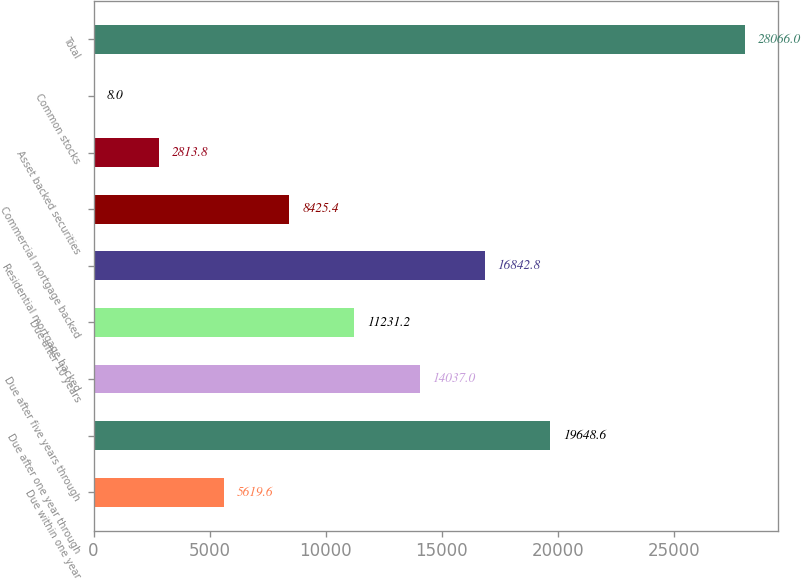Convert chart. <chart><loc_0><loc_0><loc_500><loc_500><bar_chart><fcel>Due within one year<fcel>Due after one year through<fcel>Due after five years through<fcel>Due after 10 years<fcel>Residential mortgage backed<fcel>Commercial mortgage backed<fcel>Asset backed securities<fcel>Common stocks<fcel>Total<nl><fcel>5619.6<fcel>19648.6<fcel>14037<fcel>11231.2<fcel>16842.8<fcel>8425.4<fcel>2813.8<fcel>8<fcel>28066<nl></chart> 